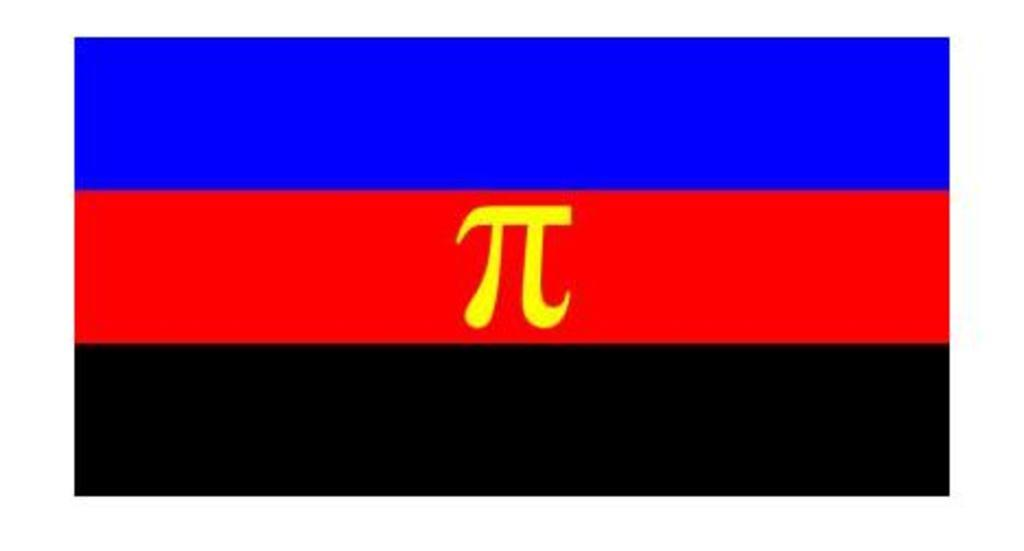What can be seen in the picture? There is a flag in the picture. Can you describe the colors of the flag? The flag has blue, red, and black lines. Is there any symbol on the flag? Yes, there is a pi symbol in the middle of the flag. How many matches are on the flag in the image? There are no matches present in the image; it features a flag with blue, red, and black lines and a pi symbol. What type of books can be seen on the flag in the image? There are no books present on the flag in the image; it features a pi symbol and colored lines. 